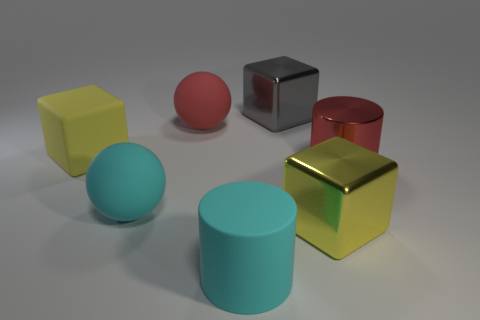What size is the yellow shiny block?
Give a very brief answer. Large. Are there fewer big rubber cylinders in front of the gray cube than brown things?
Offer a very short reply. No. Is the yellow metal cube the same size as the yellow matte block?
Ensure brevity in your answer.  Yes. There is a cylinder that is the same material as the gray object; what is its color?
Offer a terse response. Red. Is the number of big things that are behind the cyan rubber ball less than the number of things that are in front of the gray object?
Your answer should be compact. Yes. What number of rubber things are the same color as the big matte cylinder?
Offer a terse response. 1. There is a sphere that is the same color as the large matte cylinder; what is it made of?
Offer a terse response. Rubber. How many big cubes are behind the big yellow matte thing and in front of the big cyan matte ball?
Your answer should be compact. 0. There is a sphere that is behind the big yellow cube to the left of the big gray shiny thing; what is it made of?
Give a very brief answer. Rubber. Is there a large cyan thing that has the same material as the big gray block?
Keep it short and to the point. No. 